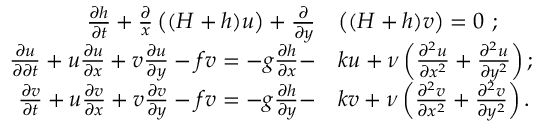<formula> <loc_0><loc_0><loc_500><loc_500>\begin{array} { r l } { \frac { \partial h } { \partial t } + \frac { \partial } { x } \left ( ( H + h ) u \right ) + \frac { \partial } { \partial y } } & { \left ( ( H + h ) v \right ) = 0 \ ; } \\ { \frac { \partial u } { \partial \partial t } + u \frac { \partial u } { \partial x } + v \frac { \partial u } { \partial y } - f v = - g \frac { \partial h } { \partial x } - } & { k u + \nu \left ( \frac { \partial ^ { 2 } u } { \partial x ^ { 2 } } + \frac { \partial ^ { 2 } u } { \partial y ^ { 2 } } \right ) ; } \\ { \frac { \partial v } { \partial t } + u \frac { \partial v } { \partial x } + v \frac { \partial v } { \partial y } - f v = - g \frac { \partial h } { \partial y } - } & { k v + \nu \left ( \frac { \partial ^ { 2 } v } { \partial x ^ { 2 } } + \frac { \partial ^ { 2 } v } { \partial y ^ { 2 } } \right ) . } \end{array}</formula> 